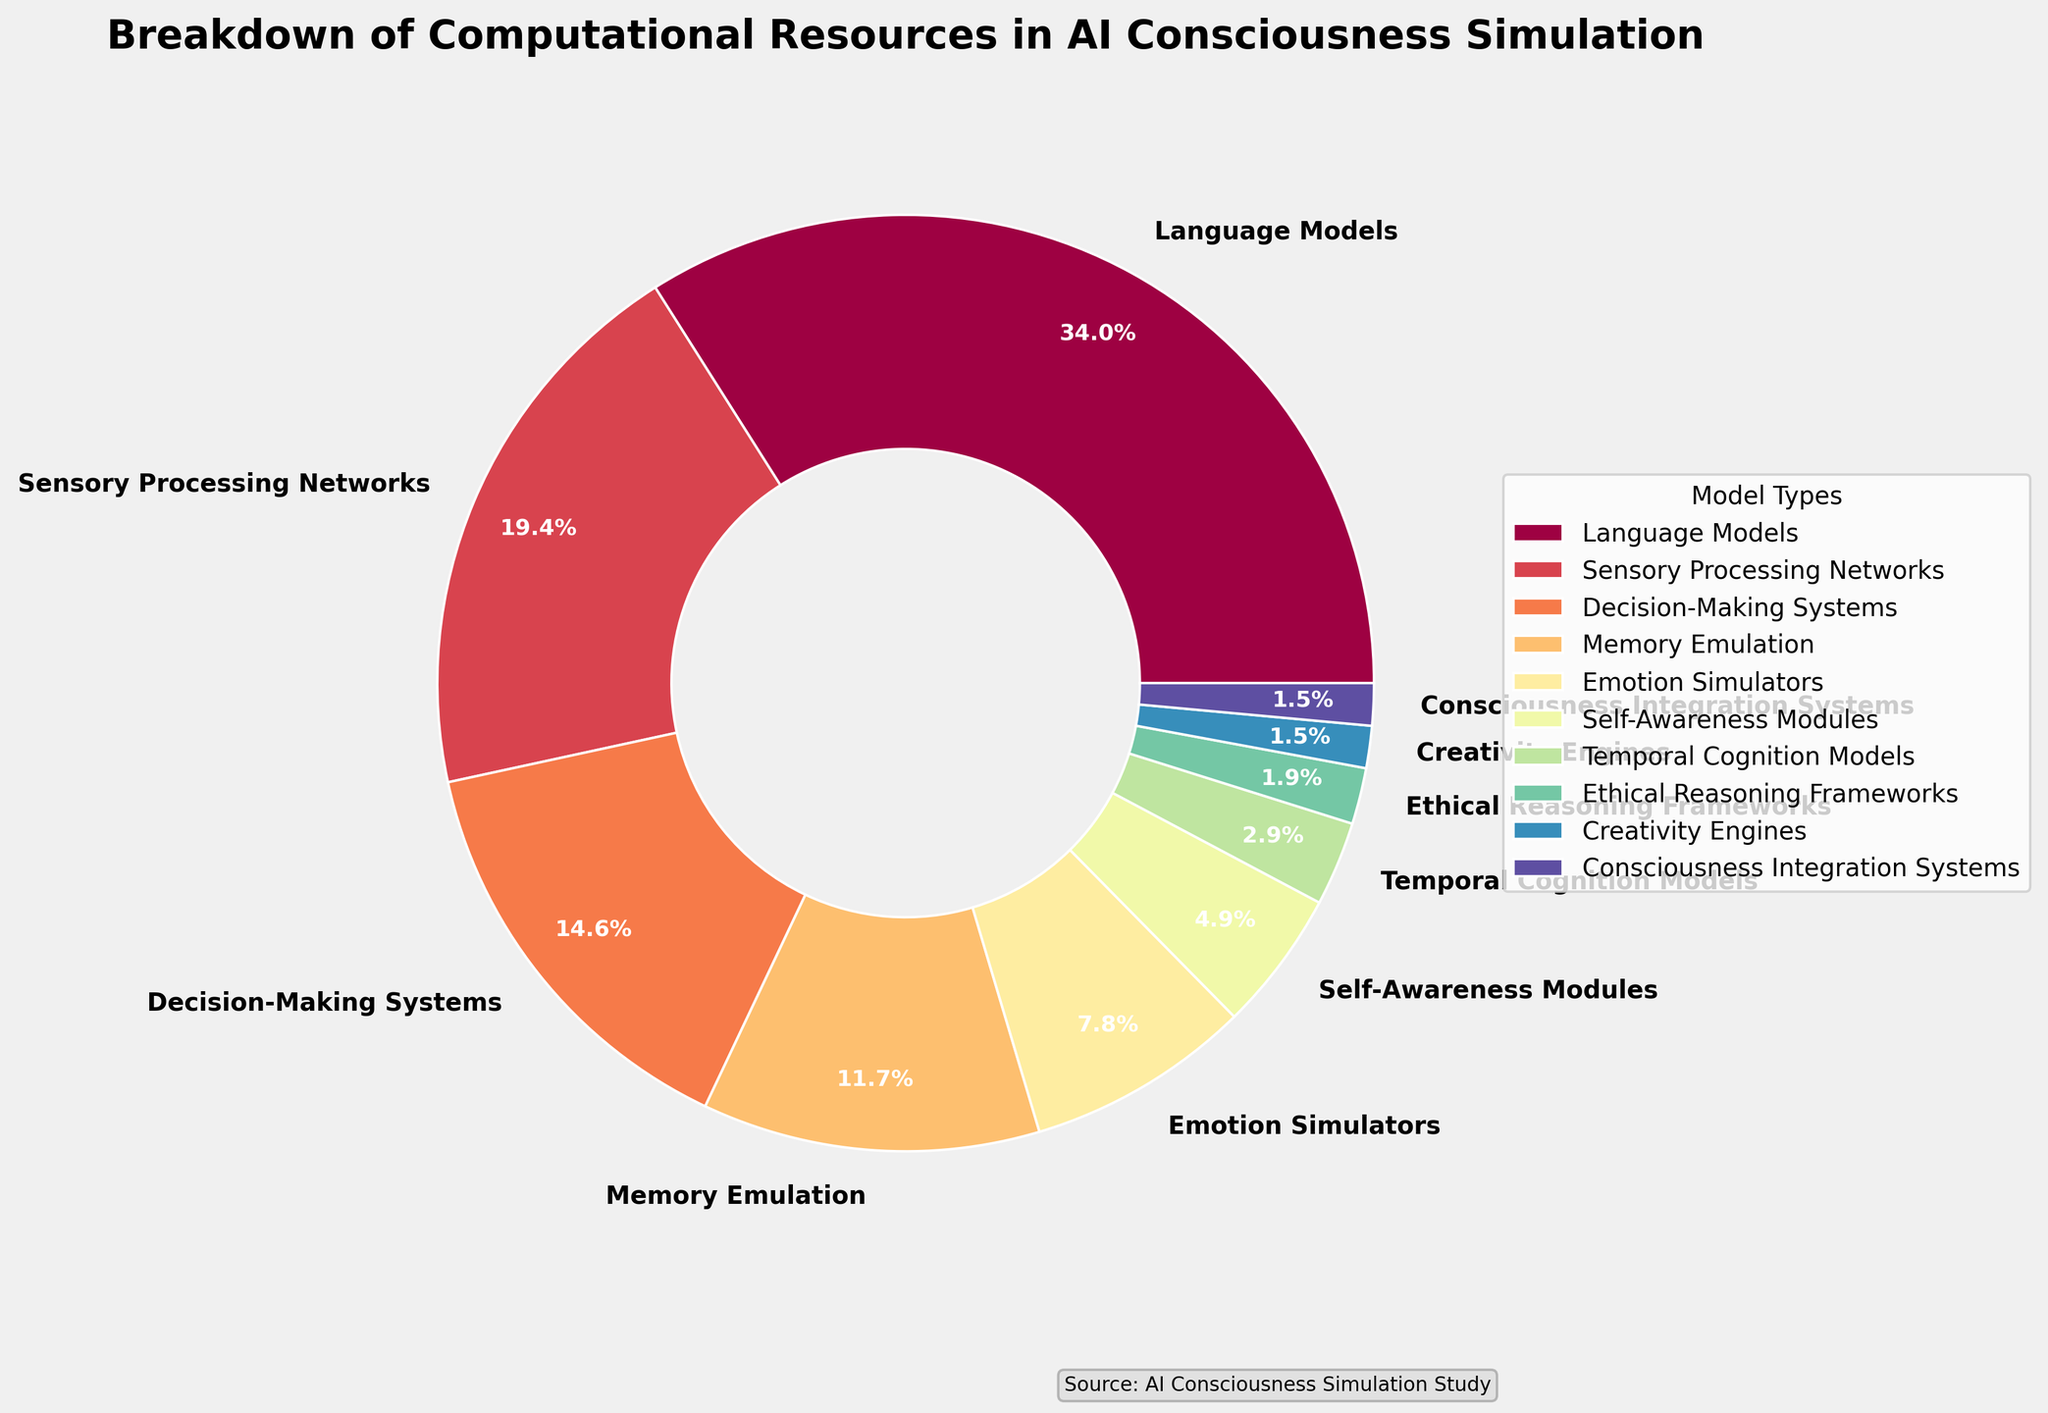Which model type has the highest allocation percentage? The pie chart shows various model types with their respective percentage allocations. By observing the chart, we can see that the "Language Models" segment is the largest.
Answer: Language Models Which two model types have equal allocation percentages? On examining the slices of the pie chart, "Creativity Engines" and "Consciousness Integration Systems" both have the same allocation percentage.
Answer: Creativity Engines and Consciousness Integration Systems How much greater is the allocation percentage of Sensory Processing Networks compared to Memory Emulation? The allocation for Sensory Processing Networks is 20%, and for Memory Emulation, it is 12%. Subtracting these values gives 20% - 12% = 8%.
Answer: 8% What is the combined allocation percentage of Decision-Making Systems and Emotion Simulators? Decision-Making Systems have a percentage of 15%, and Emotion Simulators have 8%. Adding these gives 15% + 8% = 23%.
Answer: 23% Which model type has a lower allocation percentage than Emotion Simulators but higher than Consciousness Integration Systems? Observing the chart, Self-Awareness Modules have an allocation of 5%, which is more than the 1.5% for Consciousness Integration Systems but less than the 8% for Emotion Simulators.
Answer: Self-Awareness Modules What's the ratio of the allocation percentage of Language Models to Ethical Reasoning Frameworks? The allocation for Language Models is 35%, and for Ethical Reasoning Frameworks, it is 2%. The ratio is 35% / 2% = 17.5.
Answer: 17.5 What is the total allocation percentage of the models that have less than 10% allocation each? The models with less than 10% allocation are Emotion Simulators (8%), Self-Awareness Modules (5%), Temporal Cognition Models (3%), Ethical Reasoning Frameworks (2%), Creativity Engines (1.5%), and Consciousness Integration Systems (1.5%). Summing these gives 8% + 5% + 3% + 2% + 1.5% + 1.5% = 21%.
Answer: 21% Which color represents the Sensory Processing Networks in the pie chart? The Sensory Processing Networks segment is represented by observing the second largest segment which has a corresponding distinctive color unique to that slice. This can be identified directly from the visual representation.
Answer: (This answer would be color-based from the actual plot) Which two model types together make up less than the allocation of the Memory Emulation system? Memory Emulation has 12%. The combined allocation of models less than this are Self-Awareness Modules (5%) and Temporal Cognition Models (3%) which together make 5% + 3% = 8%, fitting the criteria.
Answer: Self-Awareness Modules and Temporal Cognition Models What is the difference in allocation percentages between the model with the highest allocation and the one with the lowest allocation? Language Models have the highest allocation of 35%, while Creativity Engines and Consciousness Integration Systems have the lowest at 1.5% each. The difference is 35% - 1.5% = 33.5%.
Answer: 33.5% 